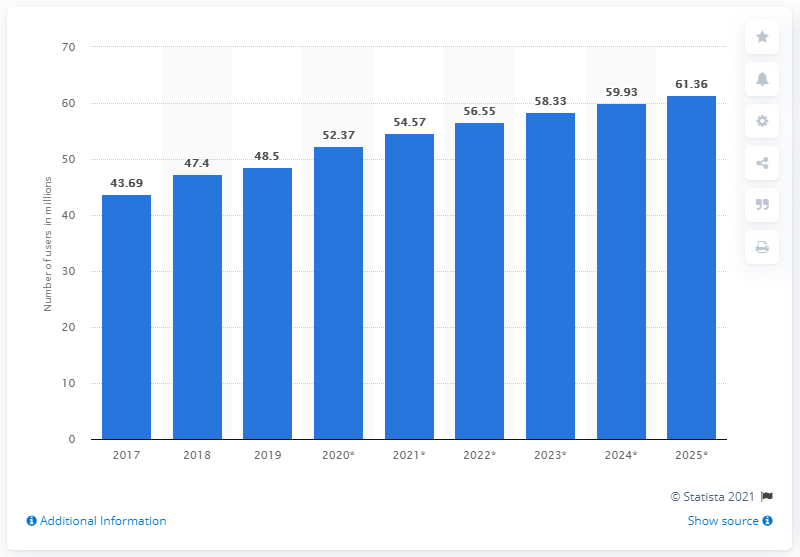Point out several critical features in this image. In 2019, the total number of Facebook users in Thailand was 48.5 million. In the second quarter of 2019, a total of 48.5 people used Facebook in Thailand. 